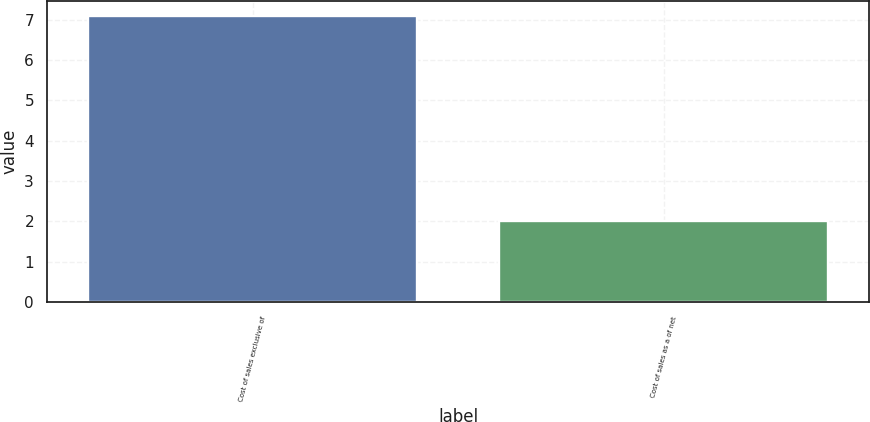Convert chart. <chart><loc_0><loc_0><loc_500><loc_500><bar_chart><fcel>Cost of sales exclusive of<fcel>Cost of sales as a of net<nl><fcel>7.1<fcel>2<nl></chart> 